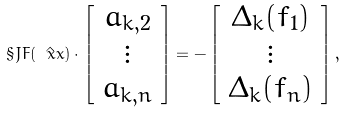Convert formula to latex. <formula><loc_0><loc_0><loc_500><loc_500>\S J F ( \hat { \ x x } ) \cdot \left [ \begin{array} { c } a _ { k , 2 } \\ \vdots \\ a _ { k , n } \end{array} \right ] = - \left [ \begin{array} { c } \Delta _ { k } ( f _ { 1 } ) \\ \vdots \\ \Delta _ { k } ( f _ { n } ) \end{array} \right ] ,</formula> 